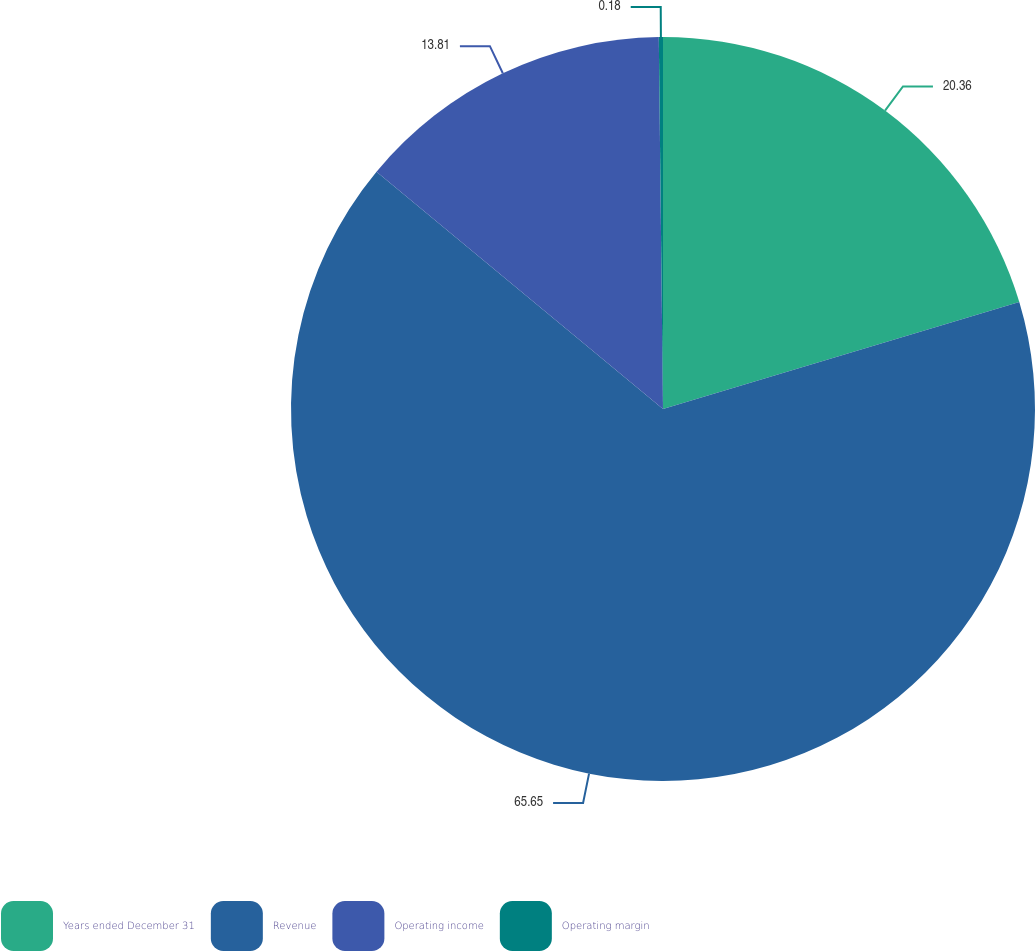<chart> <loc_0><loc_0><loc_500><loc_500><pie_chart><fcel>Years ended December 31<fcel>Revenue<fcel>Operating income<fcel>Operating margin<nl><fcel>20.36%<fcel>65.65%<fcel>13.81%<fcel>0.18%<nl></chart> 